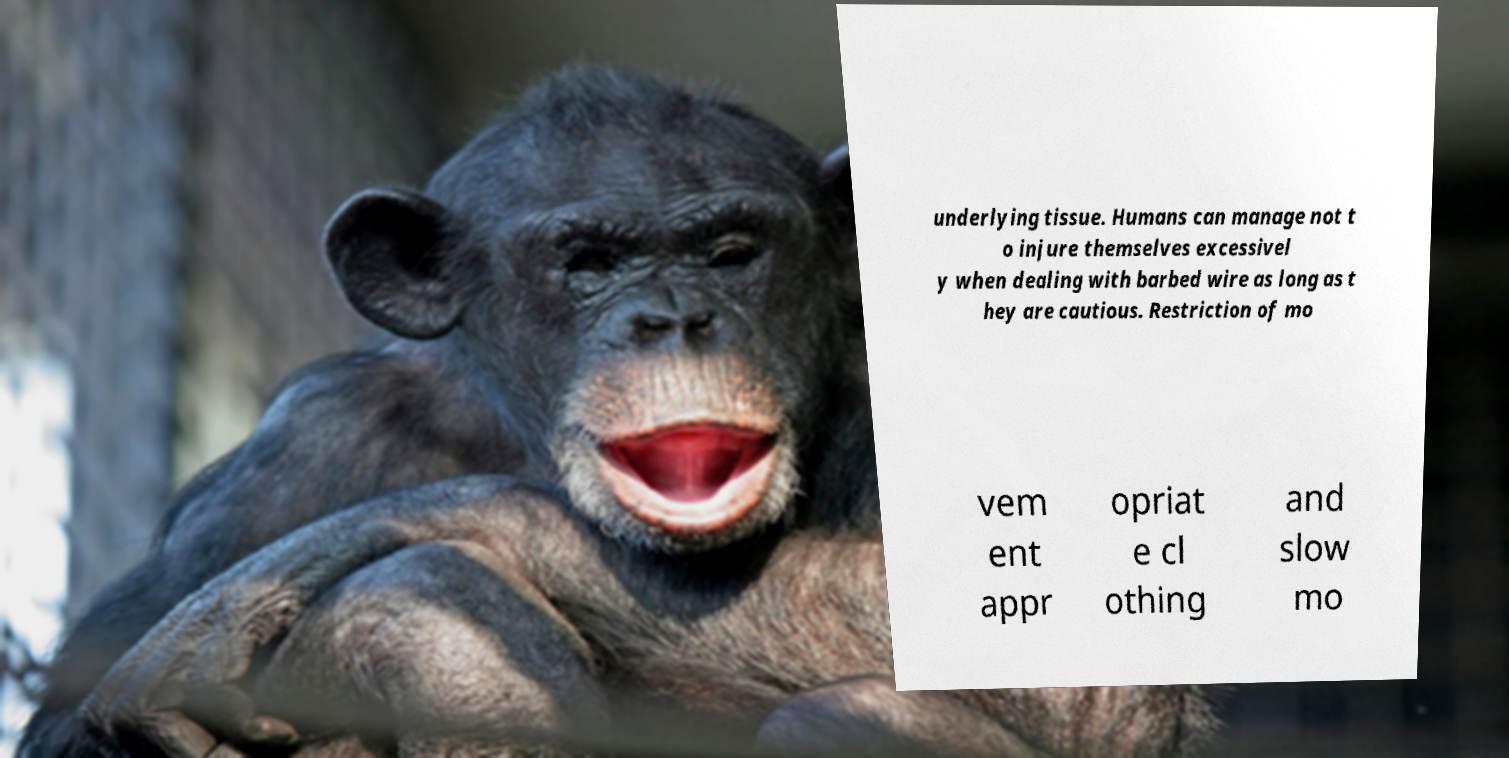For documentation purposes, I need the text within this image transcribed. Could you provide that? underlying tissue. Humans can manage not t o injure themselves excessivel y when dealing with barbed wire as long as t hey are cautious. Restriction of mo vem ent appr opriat e cl othing and slow mo 